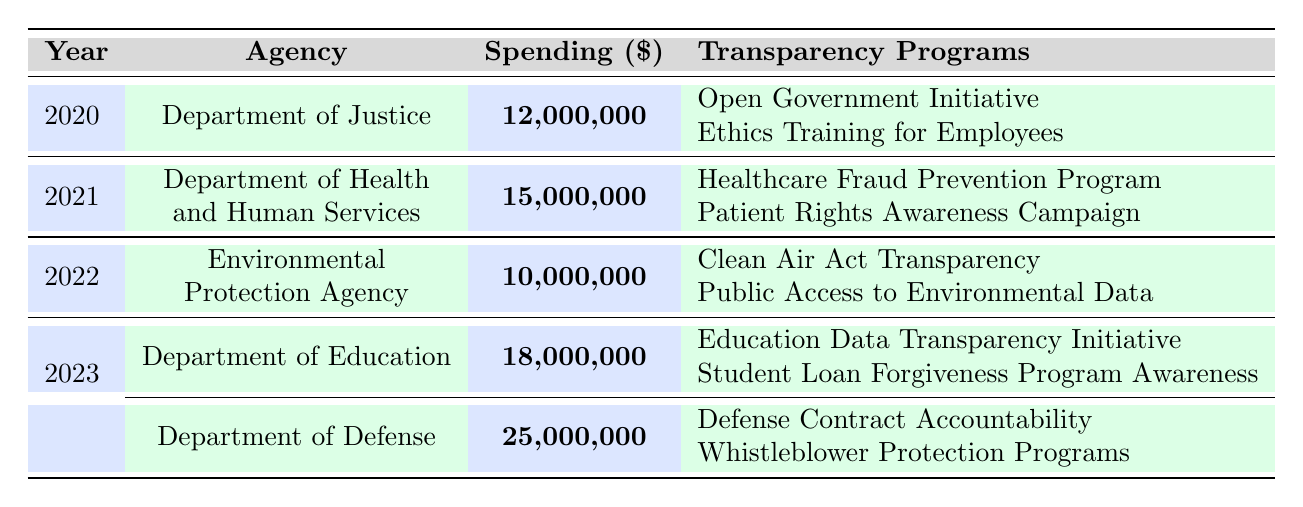What is the highest spending on transparency measures in 2023? In 2023, the Department of Defense has the highest spending on transparency measures at $25,000,000, compared to the Department of Education's $18,000,000.
Answer: $25,000,000 Which agency spent the least on transparency measures? The agency with the least spending on transparency measures is the Environmental Protection Agency with $10,000,000 in 2022.
Answer: $10,000,000 How much more did the Department of Education spend compared to the Environmental Protection Agency in 2022? The Department of Education spent $18,000,000 in 2023 while the Environmental Protection Agency spent $10,000,000 in 2022. The difference is $18,000,000 - $10,000,000 = $8,000,000.
Answer: $8,000,000 What is the total procurement spending on transparency measures from 2020 to 2023? The total spending from all years is $12,000,000 + $15,000,000 + $10,000,000 + $18,000,000 + $25,000,000 = $80,000,000.
Answer: $80,000,000 Did the Department of Justice spend less than $15 million on transparency measures? The Department of Justice spent $12,000,000, which is less than $15,000,000.
Answer: Yes What is the average spending per year on transparency measures from 2020 to 2023? The total spending is $80,000,000, and there are 5 years (2020-2023), so the average spending is $80,000,000 / 5 = $16,000,000.
Answer: $16,000,000 Which two agencies had transparency programs related to accountability? The Department of Defense had programs related to accountability: "Defense Contract Accountability" and "Whistleblower Protection Programs." No other agency in this table listed programs specifically related to accountability.
Answer: Department of Defense How many agencies implemented transparency programs in 2021? In 2021, only the Department of Health and Human Services is listed, which implemented two transparency programs: "Healthcare Fraud Prevention Program" and "Patient Rights Awareness Campaign."
Answer: 1 